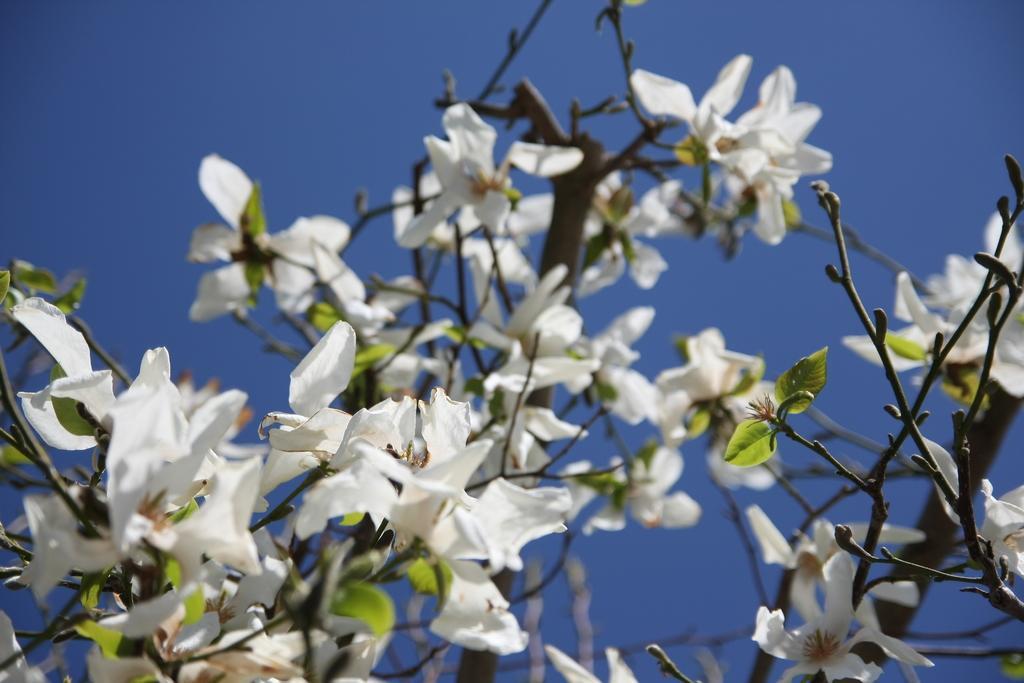Can you describe this image briefly? In this picture we can see flower plant and blue sky. 